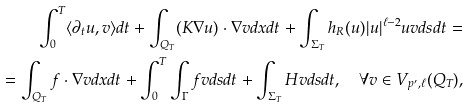<formula> <loc_0><loc_0><loc_500><loc_500>\int _ { 0 } ^ { T } \langle \partial _ { t } u , v \rangle d t + \int _ { Q _ { T } } ( K \nabla u ) \cdot \nabla v d x d t + \int _ { \Sigma _ { T } } h _ { R } ( u ) | u | ^ { \ell - 2 } u v d s d t = \\ = \int _ { Q _ { T } } { f } \cdot \nabla v d x d t + \int _ { 0 } ^ { T } \int _ { \Gamma } f v d s d t + \int _ { \Sigma _ { T } } H v d s d t , \quad \forall v \in V _ { p ^ { \prime } , \ell } ( Q _ { T } ) ,</formula> 